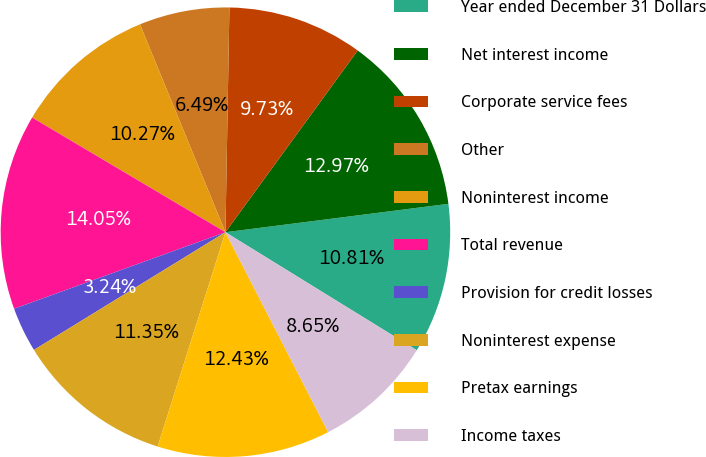Convert chart to OTSL. <chart><loc_0><loc_0><loc_500><loc_500><pie_chart><fcel>Year ended December 31 Dollars<fcel>Net interest income<fcel>Corporate service fees<fcel>Other<fcel>Noninterest income<fcel>Total revenue<fcel>Provision for credit losses<fcel>Noninterest expense<fcel>Pretax earnings<fcel>Income taxes<nl><fcel>10.81%<fcel>12.97%<fcel>9.73%<fcel>6.49%<fcel>10.27%<fcel>14.05%<fcel>3.24%<fcel>11.35%<fcel>12.43%<fcel>8.65%<nl></chart> 